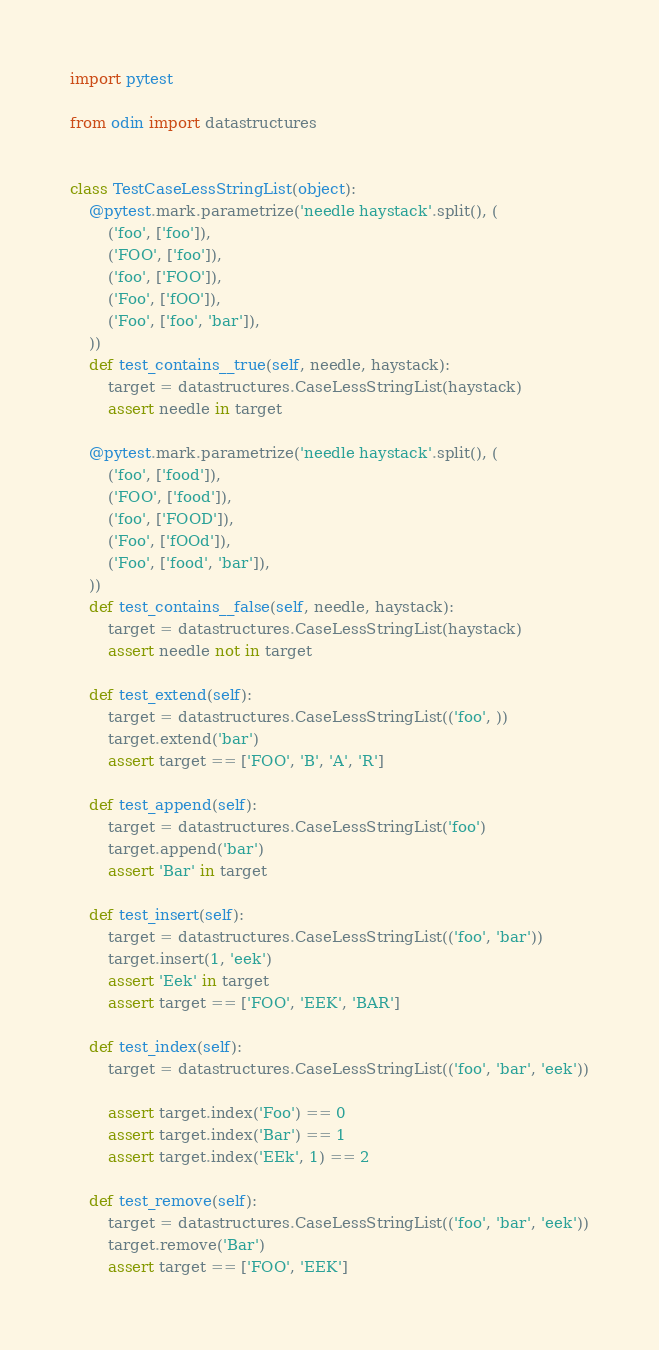Convert code to text. <code><loc_0><loc_0><loc_500><loc_500><_Python_>import pytest

from odin import datastructures


class TestCaseLessStringList(object):
    @pytest.mark.parametrize('needle haystack'.split(), (
        ('foo', ['foo']),
        ('FOO', ['foo']),
        ('foo', ['FOO']),
        ('Foo', ['fOO']),
        ('Foo', ['foo', 'bar']),
    ))
    def test_contains__true(self, needle, haystack):
        target = datastructures.CaseLessStringList(haystack)
        assert needle in target

    @pytest.mark.parametrize('needle haystack'.split(), (
        ('foo', ['food']),
        ('FOO', ['food']),
        ('foo', ['FOOD']),
        ('Foo', ['fOOd']),
        ('Foo', ['food', 'bar']),
    ))
    def test_contains__false(self, needle, haystack):
        target = datastructures.CaseLessStringList(haystack)
        assert needle not in target

    def test_extend(self):
        target = datastructures.CaseLessStringList(('foo', ))
        target.extend('bar')
        assert target == ['FOO', 'B', 'A', 'R']

    def test_append(self):
        target = datastructures.CaseLessStringList('foo')
        target.append('bar')
        assert 'Bar' in target

    def test_insert(self):
        target = datastructures.CaseLessStringList(('foo', 'bar'))
        target.insert(1, 'eek')
        assert 'Eek' in target
        assert target == ['FOO', 'EEK', 'BAR']

    def test_index(self):
        target = datastructures.CaseLessStringList(('foo', 'bar', 'eek'))

        assert target.index('Foo') == 0
        assert target.index('Bar') == 1
        assert target.index('EEk', 1) == 2

    def test_remove(self):
        target = datastructures.CaseLessStringList(('foo', 'bar', 'eek'))
        target.remove('Bar')
        assert target == ['FOO', 'EEK']
</code> 